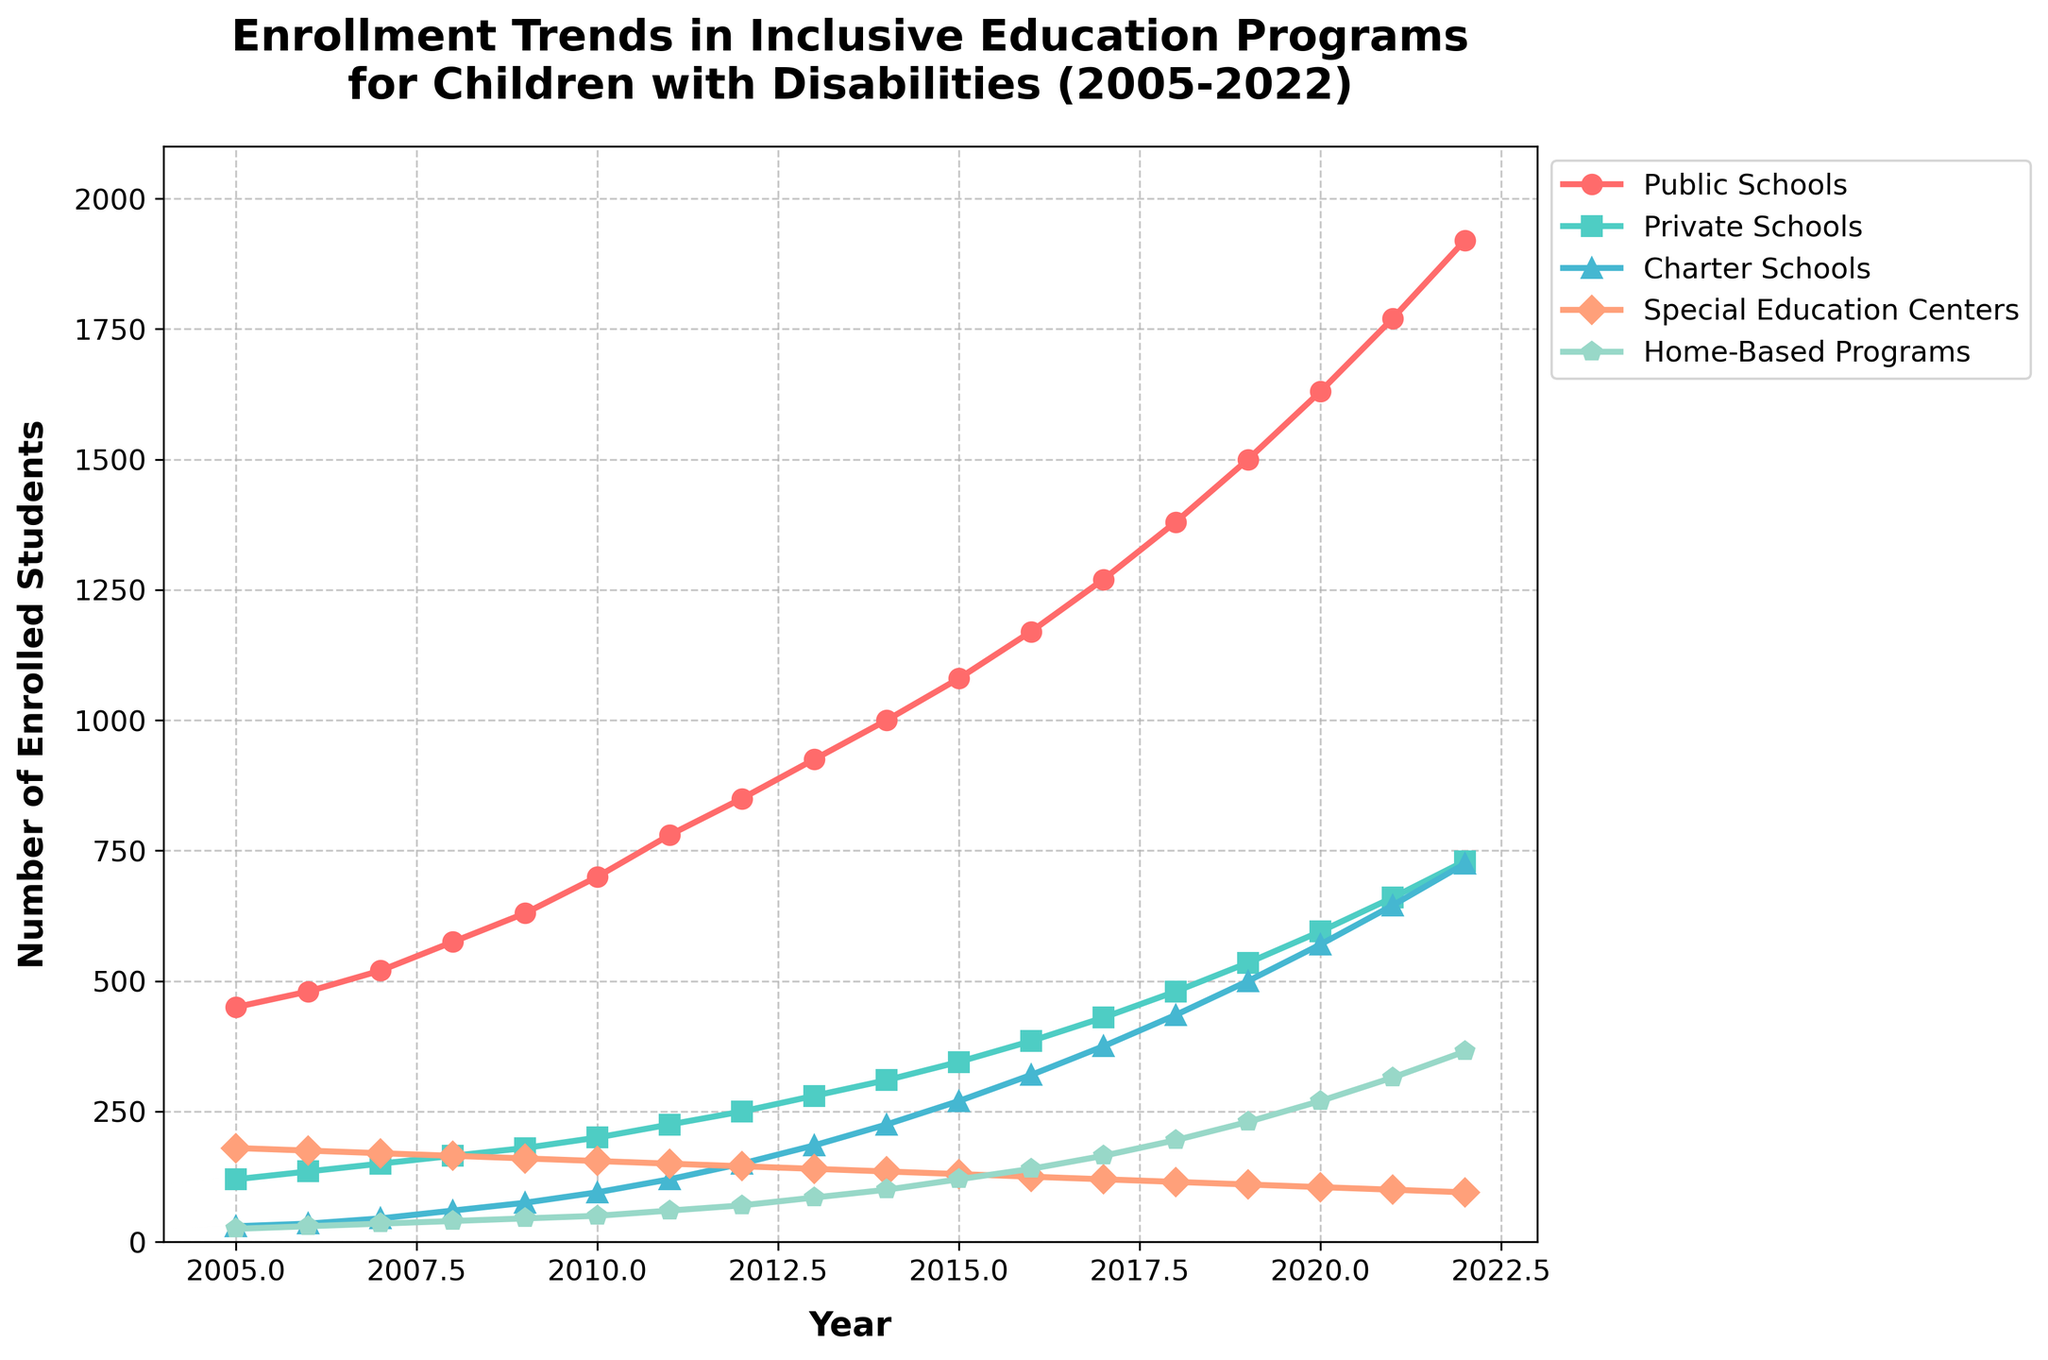What was the enrollment in Public Schools in 2010 compared to Private Schools in the same year? In 2010, the enrollment in Public Schools was 700, and for Private Schools, it was 200.
Answer: Public Schools: 700, Private Schools: 200 Which program had a continuous increase in enrollment every year from 2005 to 2022? By following the lines on the graph, we see that Home-Based Programs had a consistent upward trend each year.
Answer: Home-Based Programs What is the total increase in enrollment for Special Education Centers from 2005 to 2022? In 2022, the enrollment was 95, and in 2005 it was 180. The total increase is 95 - 180 = -85.
Answer: -85 How does the enrollment trend in Charter Schools from 2009 to 2014 compare with that of Public Schools in the same period? From 2009 to 2014, enrollment in Charter Schools increased from 75 to 225, an increase of 150. In the same period, Public Schools increased from 630 to 1000, an increase of 370.
Answer: Charter Schools: +150, Public Schools: +370 Between 2015 and 2020, which program saw the most significant absolute increase in enrollment numbers? From 2015 to 2020, Public Schools increased from 1080 to 1630 (increase of 550), Private Schools from 345 to 595 (increase of 250), Charter Schools from 270 to 570 (increase of 300), Special Education Centers from 130 to 105 (decrease of 25), and Home-Based Programs from 120 to 270 (increase of 150). The most significant increase was in Public Schools.
Answer: Public Schools What is the visual attribute that differentiates the line representing Enrollment in Home-Based Programs from the others? The line representing Enrollment in Home-Based Programs is marked with a "p" shaped marker.
Answer: "p" shaped marker In which year did Private Schools and Special Education Centers have the same enrollment? By looking at the lines, it is clear that in no year did the enrollment numbers of Private Schools and Special Education Centers intersect.
Answer: Never What was the average enrollment in with Home-Based Programs from 2005 to 2020? Sum up the enrollment numbers for Home-Based Programs from 2005 to 2020: 25 + 30 + 35 + 40 + 45 + 50 + 60 + 70 + 85 + 100 + 120 + 140 + 165 + 195 + 230 + 270 = 1630, then divide by the number of years (16). The average is 1630 / 16 = 101.875.
Answer: Approximately 101.88 